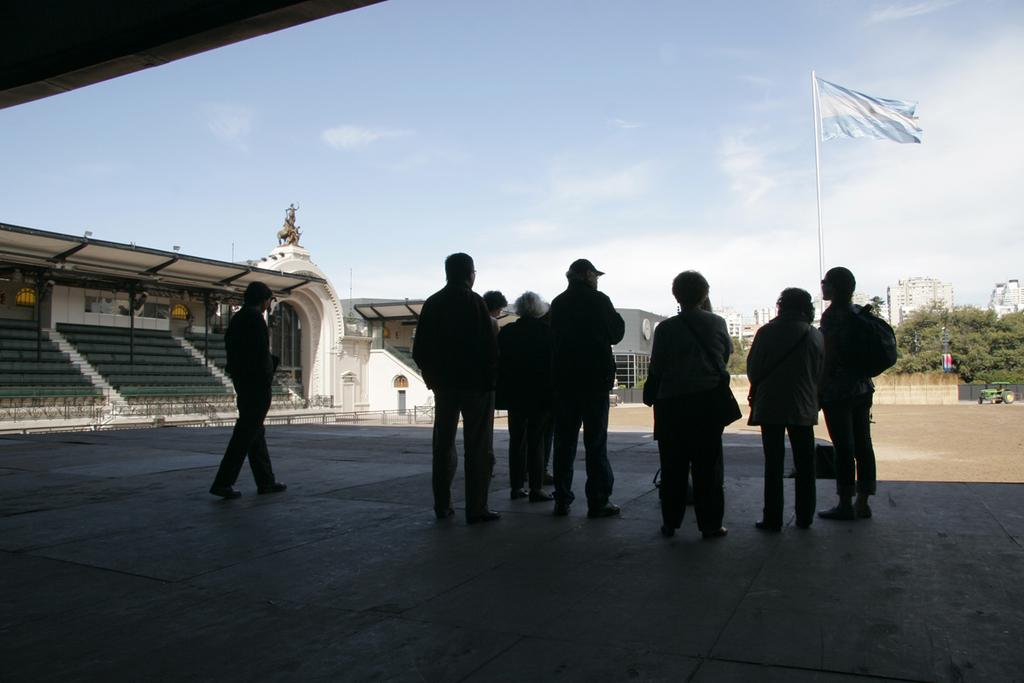How many people can be seen in the image? There are people in the image. What type of structures are present in the image? There are open-sheds, buildings, and an arch in the image. What type of vegetation is visible in the image? There are trees in the image. What type of seating is available in the image? There are benches in the image. What type of support structures are present in the image? There are poles in the image. What type of symbol is visible in the image? There is a flag in the image. What type of transportation is present in the image? There is a vehicle in the image. What is the condition of the sky in the image? There is a cloudy sky in the image. What is located above the arch in the image? Above the arch, there is a statue in the image. How many oranges are being held by the sister in the image? There is no sister or oranges present in the image. What type of bubble is floating near the vehicle in the image? There is no bubble present in the image. 